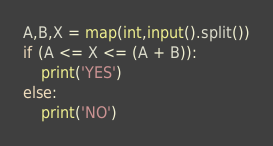Convert code to text. <code><loc_0><loc_0><loc_500><loc_500><_Python_>A,B,X = map(int,input().split())
if (A <= X <= (A + B)):
    print('YES')
else:
    print('NO')</code> 